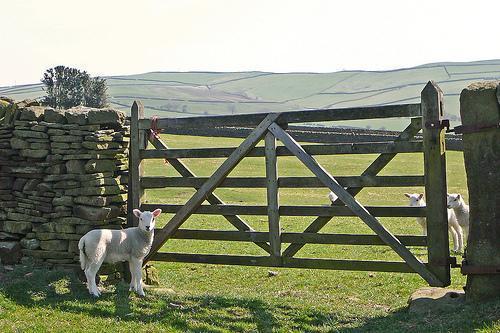How many sheep are there?
Give a very brief answer. 3. 